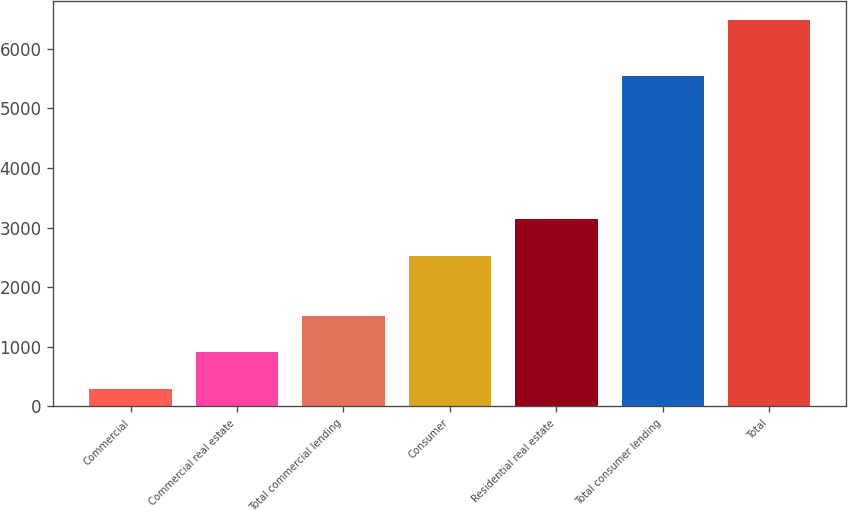<chart> <loc_0><loc_0><loc_500><loc_500><bar_chart><fcel>Commercial<fcel>Commercial real estate<fcel>Total commercial lending<fcel>Consumer<fcel>Residential real estate<fcel>Total consumer lending<fcel>Total<nl><fcel>282<fcel>902.3<fcel>1522.6<fcel>2523<fcel>3143.3<fcel>5548<fcel>6485<nl></chart> 